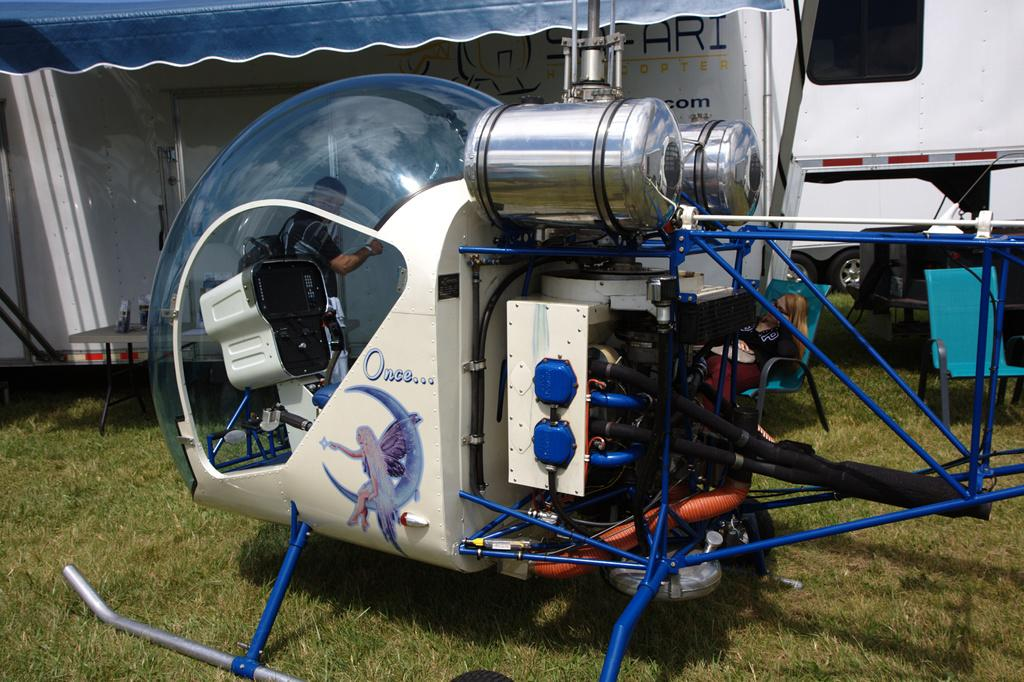What can be seen in the image related to machinery or tools? There is equipment in the image. Who or what is located in the middle of the image? There is a person in the middle of the image. What type of shelter or covering is visible at the top of the image? There is a tent-like structure at the top of the image. What mode of transportation can be seen in the image? There is a helicopter in the image. What other vehicle is present at the top of the image? There is a vehicle at the top of the image. Can you tell me how many pigs are being milked by the farmer in the image? There are no pigs or farmers present in the image. What type of animal is providing milk for the farmer in the image? There is no animal providing milk in the image, as there are no animals or farmers present. 